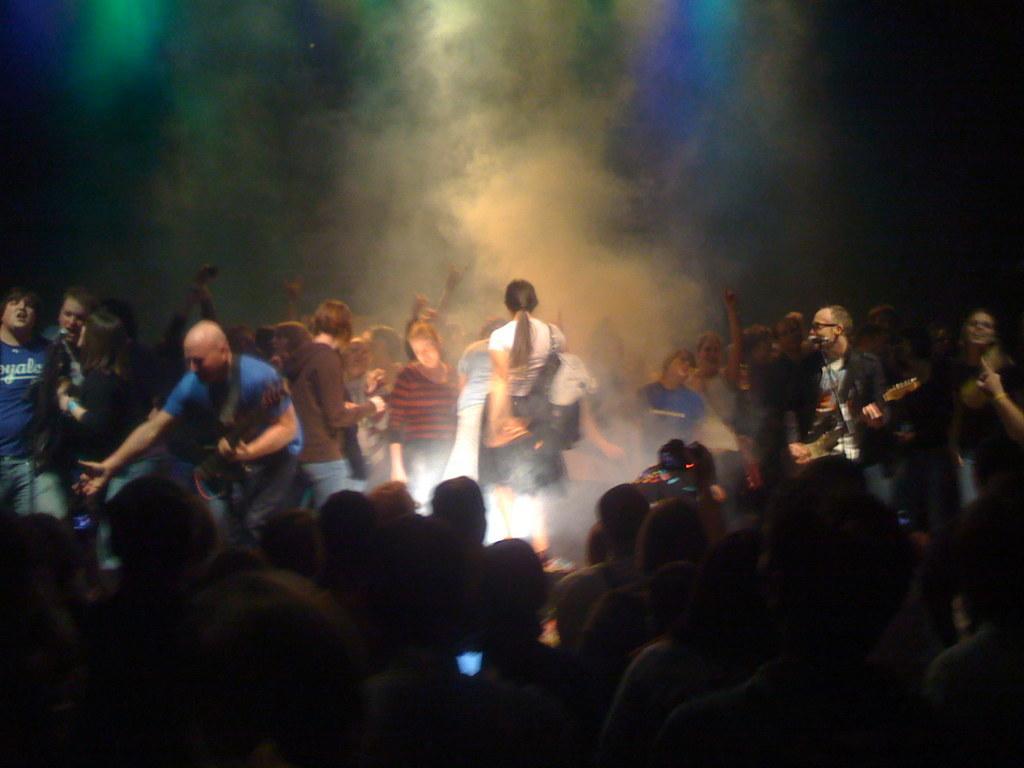Describe this image in one or two sentences. In this image I see 2 men who are holding guitars and there are mics over here and I can also people over here and here too and In the background I see the smoke and different colors. 